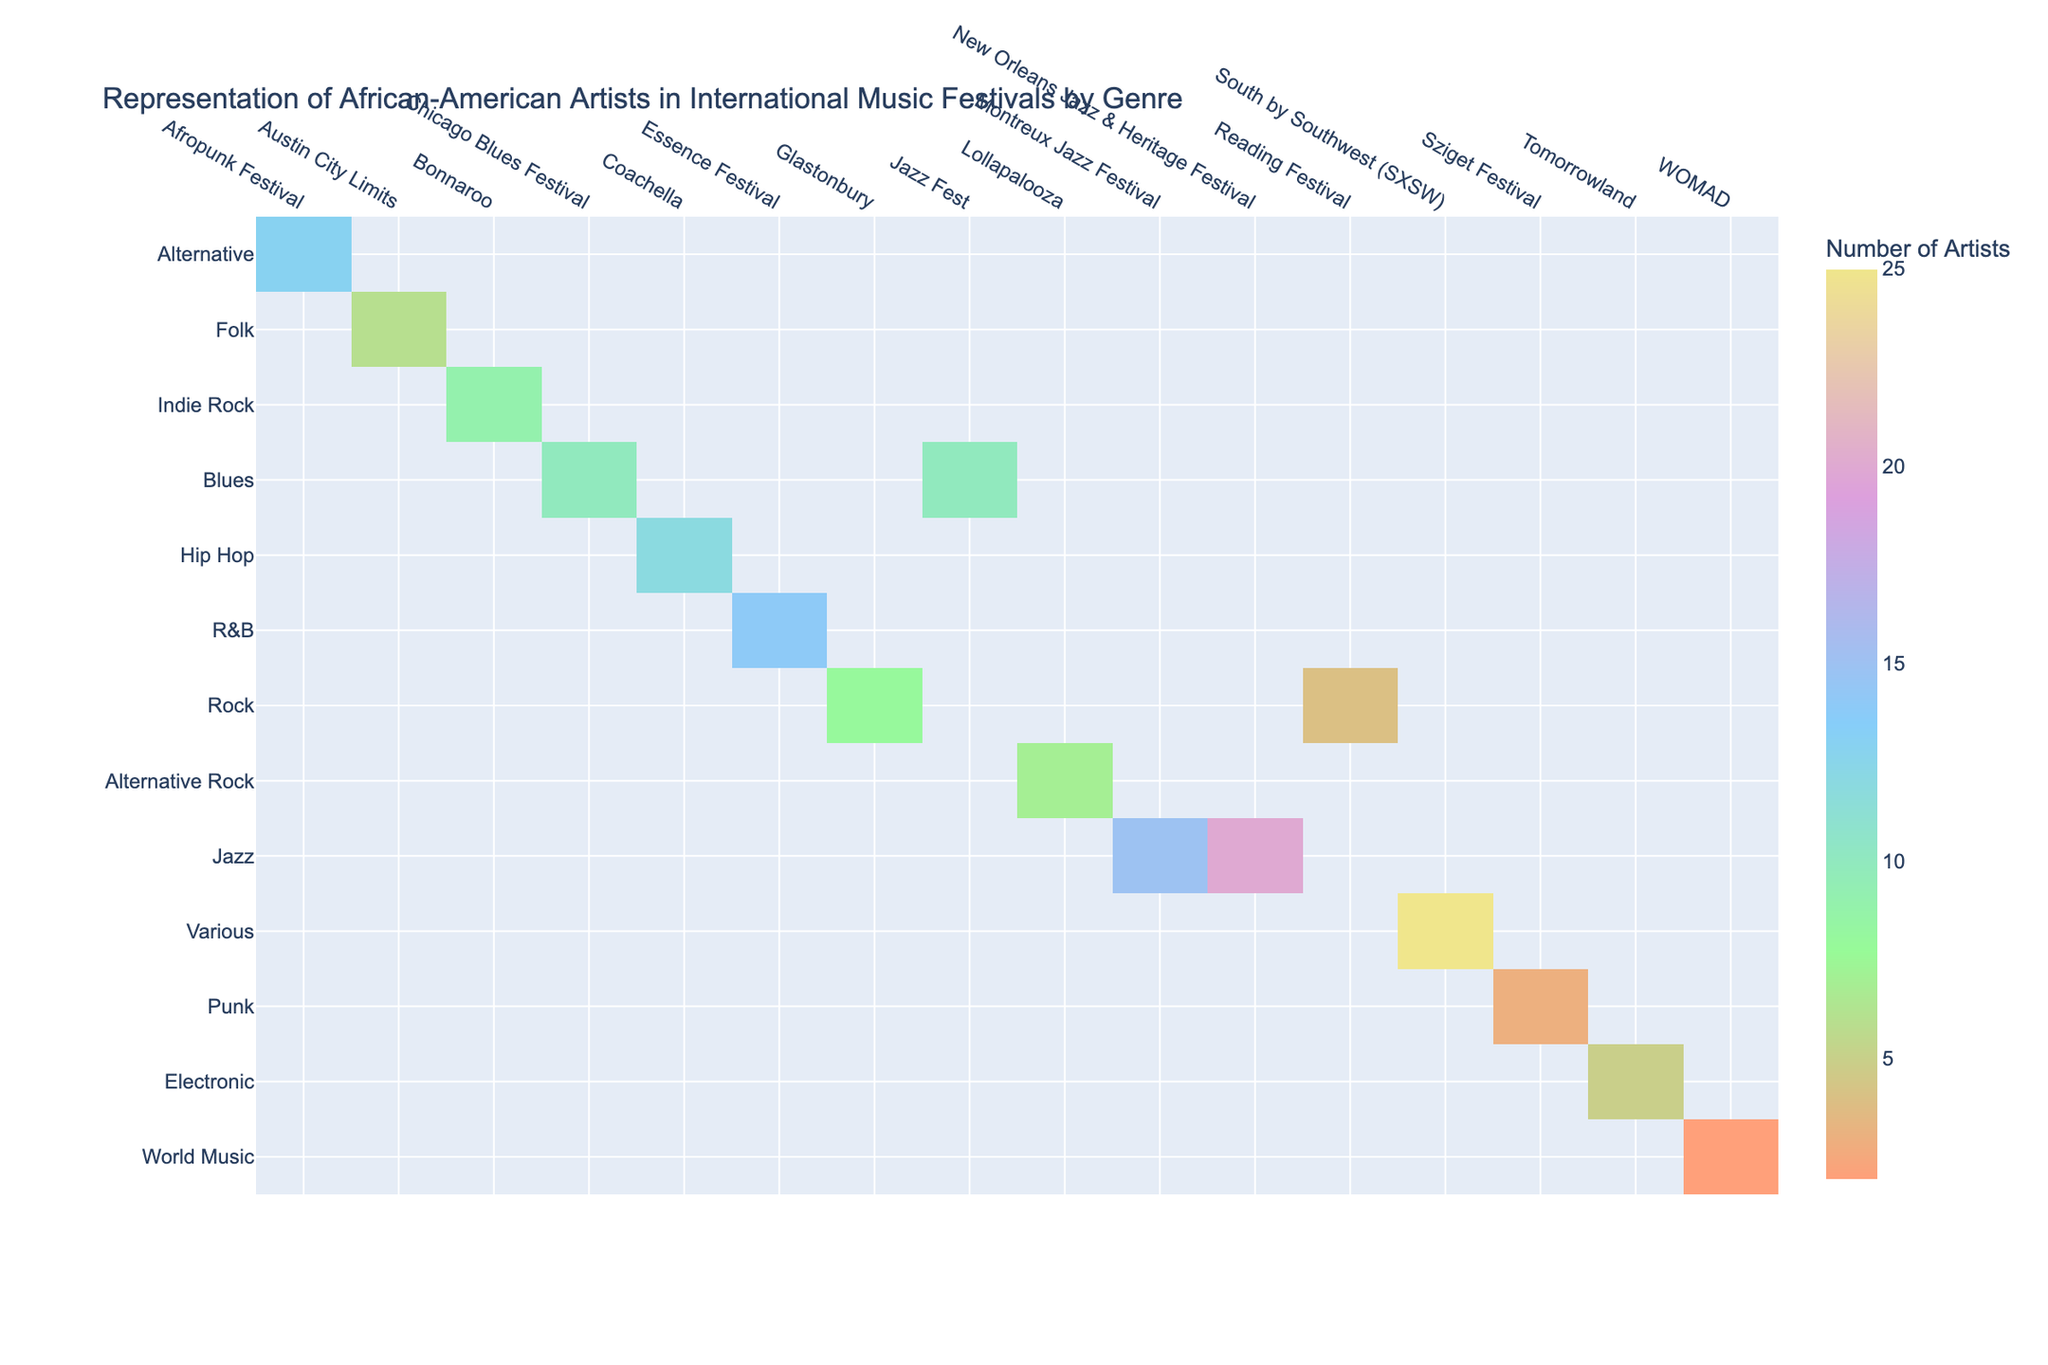What is the number of African-American artists represented at the Montreux Jazz Festival? The table shows a specific entry for the Montreux Jazz Festival under the Jazz genre, which lists 15 African-American artists.
Answer: 15 How many African-American artists are represented in Electronic music at Tomorrowland? Tomorrowland is listed as an Electronic genre festival, and the table indicates that there are 5 African-American artists represented there.
Answer: 5 Which genre has the highest representation of African-American artists at the New Orleans Jazz & Heritage Festival? The New Orleans Jazz & Heritage Festival lists 20 African-American artists and falls under the Jazz genre. It is the only genre associated with this specific festival in the table, so it has the highest representation here.
Answer: Jazz What is the total number of African-American artists across all festivals for the Rock genre? The Rock genre has two entries in the table - Glastonbury (8 artists) and Reading Festival (4 artists). Adding these gives a total of 8 + 4 = 12 African-American artists across both festivals.
Answer: 12 Is there any genre in the table that features fewer than 5 African-American artists? Checking the entries, the Punk genre at Sziget Festival has only 3 African-American artists and the World Music genre at WOMAD has 2 African-American artists. Thus, there are genres with fewer than 5 artists.
Answer: Yes What is the difference in the number of African-American artists between the South by Southwest festival and the New Orleans Jazz & Heritage Festival? South by Southwest festival has 25 artists while the New Orleans Jazz & Heritage Festival has 20 artists. Calculating the difference gives 25 - 20 = 5.
Answer: 5 Which genre has the least representation of African-American artists at any festivals? Looking at the table, the Punk genre is represented at Sziget Festival with only 3 African-American artists, which is the lowest count among all genres listed.
Answer: Punk What proportion of African-American artists at Lollapalooza belong to the Alternative Rock genre compared to the total number of artists across all genres? Lollapalooza has 7 African-American artists in the Alternative Rock genre. The total for all genres in the table sums up to 165 (by summing up each number of artists). Therefore, the proportion is 7/165 = 0.0424, or approximately 4.24%.
Answer: 4.24% Which festival has the highest number of African-American artists in the Folk genre, and how many artists were represented? The Austin City Limits festival is listed under the Folk genre and shows 6 African-American artists. This is the only entry for the Folk genre in the table, indicating that it has the highest representation.
Answer: Austin City Limits, 6 